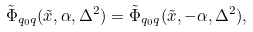<formula> <loc_0><loc_0><loc_500><loc_500>\tilde { \Phi } _ { q _ { 0 } q } ( \tilde { x } , \alpha , \Delta ^ { 2 } ) = \tilde { \Phi } _ { q _ { 0 } q } ( \tilde { x } , - \alpha , \Delta ^ { 2 } ) ,</formula> 